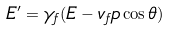<formula> <loc_0><loc_0><loc_500><loc_500>E ^ { \prime } = \gamma _ { f } ( E - v _ { f } p \cos \theta )</formula> 